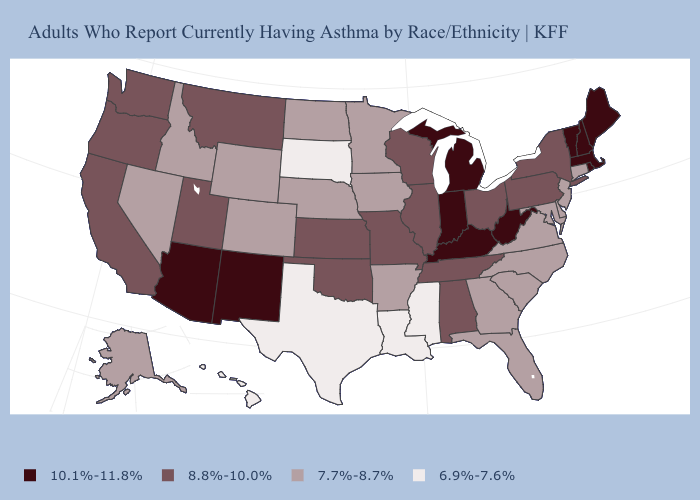Name the states that have a value in the range 6.9%-7.6%?
Keep it brief. Hawaii, Louisiana, Mississippi, South Dakota, Texas. Does West Virginia have the highest value in the South?
Give a very brief answer. Yes. Does Maryland have a higher value than Hawaii?
Be succinct. Yes. Name the states that have a value in the range 10.1%-11.8%?
Write a very short answer. Arizona, Indiana, Kentucky, Maine, Massachusetts, Michigan, New Hampshire, New Mexico, Rhode Island, Vermont, West Virginia. Name the states that have a value in the range 7.7%-8.7%?
Quick response, please. Alaska, Arkansas, Colorado, Connecticut, Delaware, Florida, Georgia, Idaho, Iowa, Maryland, Minnesota, Nebraska, Nevada, New Jersey, North Carolina, North Dakota, South Carolina, Virginia, Wyoming. Name the states that have a value in the range 8.8%-10.0%?
Answer briefly. Alabama, California, Illinois, Kansas, Missouri, Montana, New York, Ohio, Oklahoma, Oregon, Pennsylvania, Tennessee, Utah, Washington, Wisconsin. Does the first symbol in the legend represent the smallest category?
Keep it brief. No. What is the value of Illinois?
Keep it brief. 8.8%-10.0%. Does South Dakota have the lowest value in the USA?
Be succinct. Yes. Which states have the lowest value in the USA?
Concise answer only. Hawaii, Louisiana, Mississippi, South Dakota, Texas. Name the states that have a value in the range 10.1%-11.8%?
Write a very short answer. Arizona, Indiana, Kentucky, Maine, Massachusetts, Michigan, New Hampshire, New Mexico, Rhode Island, Vermont, West Virginia. What is the highest value in the MidWest ?
Keep it brief. 10.1%-11.8%. Name the states that have a value in the range 6.9%-7.6%?
Keep it brief. Hawaii, Louisiana, Mississippi, South Dakota, Texas. Does Alabama have the same value as Oklahoma?
Keep it brief. Yes. What is the value of Colorado?
Answer briefly. 7.7%-8.7%. 